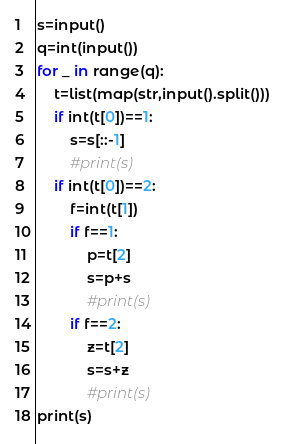<code> <loc_0><loc_0><loc_500><loc_500><_Python_>s=input()
q=int(input())
for _ in range(q):
    t=list(map(str,input().split()))
    if int(t[0])==1:
        s=s[::-1]
        #print(s)
    if int(t[0])==2:
        f=int(t[1])
        if f==1:
            p=t[2]
            s=p+s
            #print(s)
        if f==2:
            z=t[2]
            s=s+z
            #print(s)
print(s)</code> 